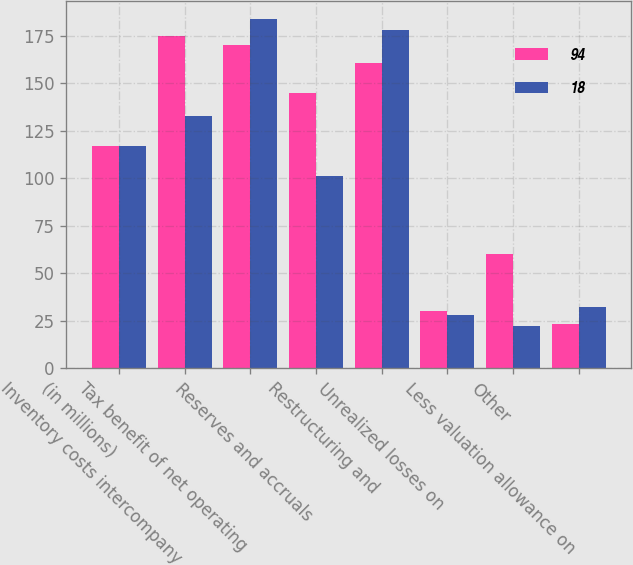<chart> <loc_0><loc_0><loc_500><loc_500><stacked_bar_chart><ecel><fcel>(in millions)<fcel>Inventory costs intercompany<fcel>Tax benefit of net operating<fcel>Reserves and accruals<fcel>Restructuring and<fcel>Unrealized losses on<fcel>Other<fcel>Less valuation allowance on<nl><fcel>94<fcel>117<fcel>175<fcel>170<fcel>145<fcel>161<fcel>30<fcel>60<fcel>23<nl><fcel>18<fcel>117<fcel>133<fcel>184<fcel>101<fcel>178<fcel>28<fcel>22<fcel>32<nl></chart> 